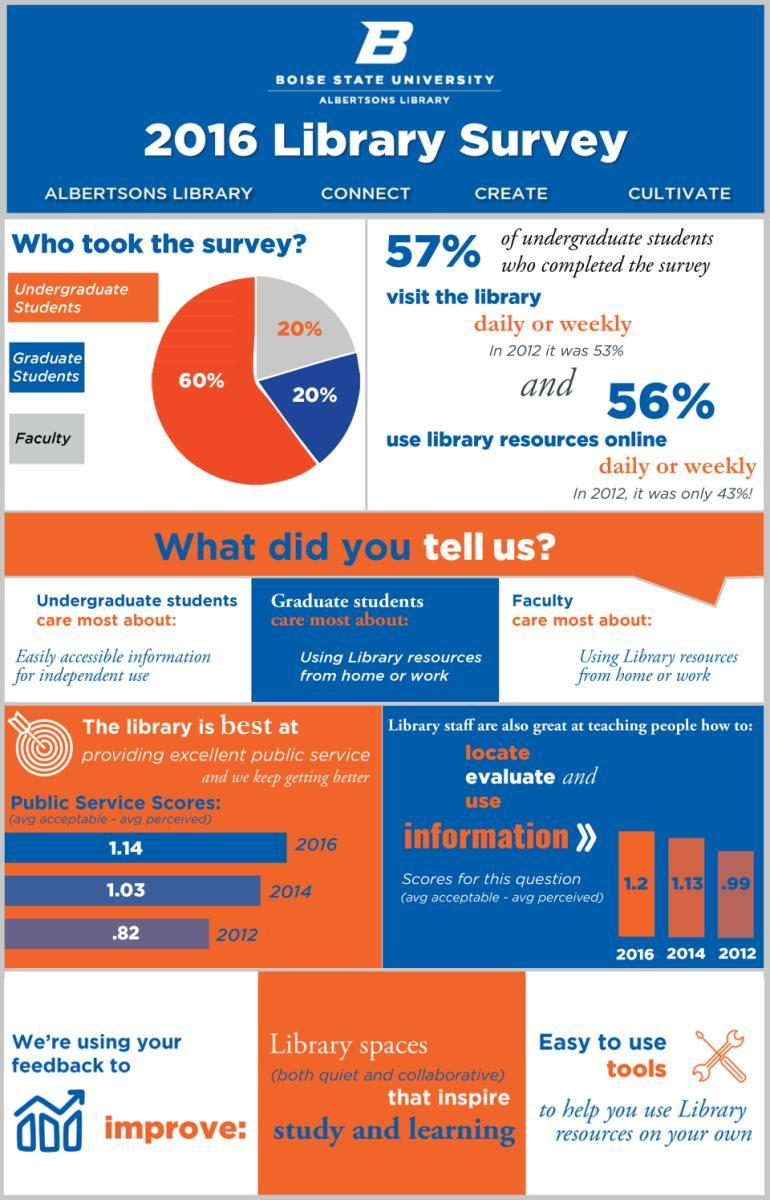What is the percentage of graduate students in Boise State University according to the 2016 library survey?
Answer the question with a short phrase. 20% What is the percentage of faculty members in Boise State University according to the 2016 library survey? 20% What is the percentage of undergraduate students in Boise State University according to the 2016 library survey? 60% 